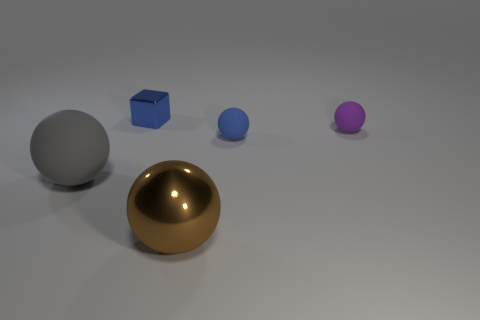Is the number of small cyan rubber spheres greater than the number of rubber things?
Offer a very short reply. No. There is a tiny ball in front of the purple matte ball; is its color the same as the small metal cube?
Ensure brevity in your answer.  Yes. The small shiny block is what color?
Make the answer very short. Blue. There is a blue object that is to the right of the large brown shiny object; is there a large brown thing to the right of it?
Make the answer very short. No. There is a small rubber object that is left of the small purple matte object in front of the small metallic thing; what is its shape?
Offer a terse response. Sphere. Are there fewer big gray rubber things than tiny shiny cylinders?
Give a very brief answer. No. Does the tiny block have the same material as the large brown object?
Give a very brief answer. Yes. There is a ball that is both left of the blue rubber object and to the right of the small blue cube; what is its color?
Keep it short and to the point. Brown. Are there any metallic objects of the same size as the cube?
Offer a very short reply. No. There is a ball to the left of the shiny object in front of the blue metal thing; what size is it?
Make the answer very short. Large. 